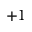Convert formula to latex. <formula><loc_0><loc_0><loc_500><loc_500>+ 1</formula> 